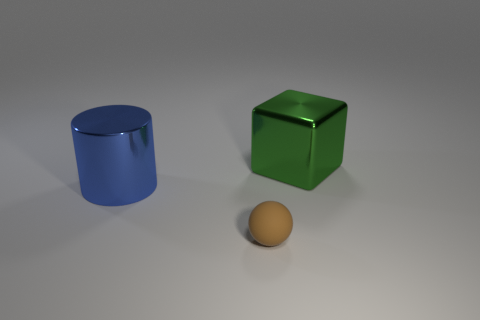Add 2 big blue things. How many objects exist? 5 Subtract all cylinders. How many objects are left? 2 Add 3 tiny matte spheres. How many tiny matte spheres are left? 4 Add 3 large shiny objects. How many large shiny objects exist? 5 Subtract 1 blue cylinders. How many objects are left? 2 Subtract all big green shiny cylinders. Subtract all metallic blocks. How many objects are left? 2 